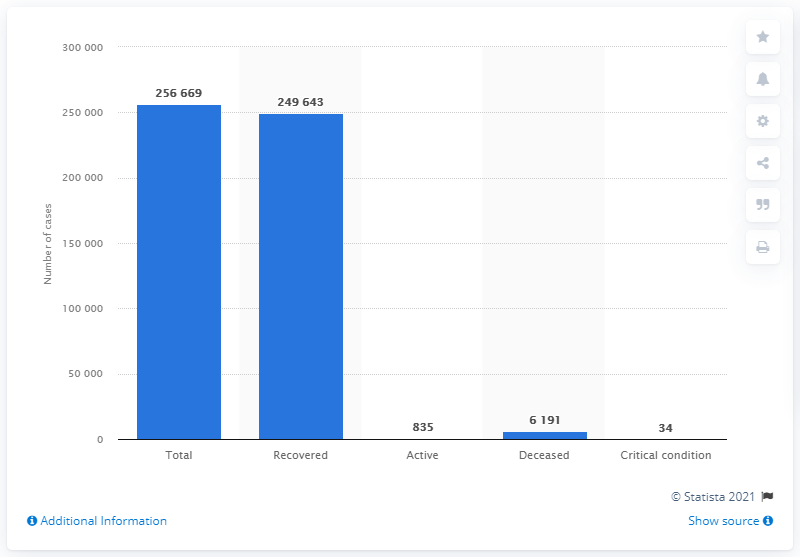Indicate a few pertinent items in this graphic. As of June 29, 2021, there were 835 active cases of COVID-19. 